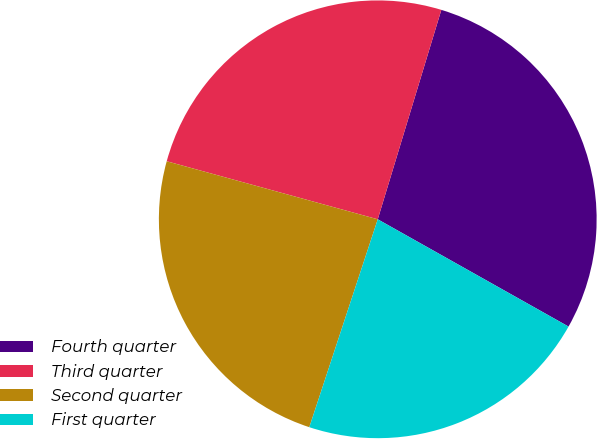Convert chart to OTSL. <chart><loc_0><loc_0><loc_500><loc_500><pie_chart><fcel>Fourth quarter<fcel>Third quarter<fcel>Second quarter<fcel>First quarter<nl><fcel>28.46%<fcel>25.42%<fcel>24.21%<fcel>21.91%<nl></chart> 